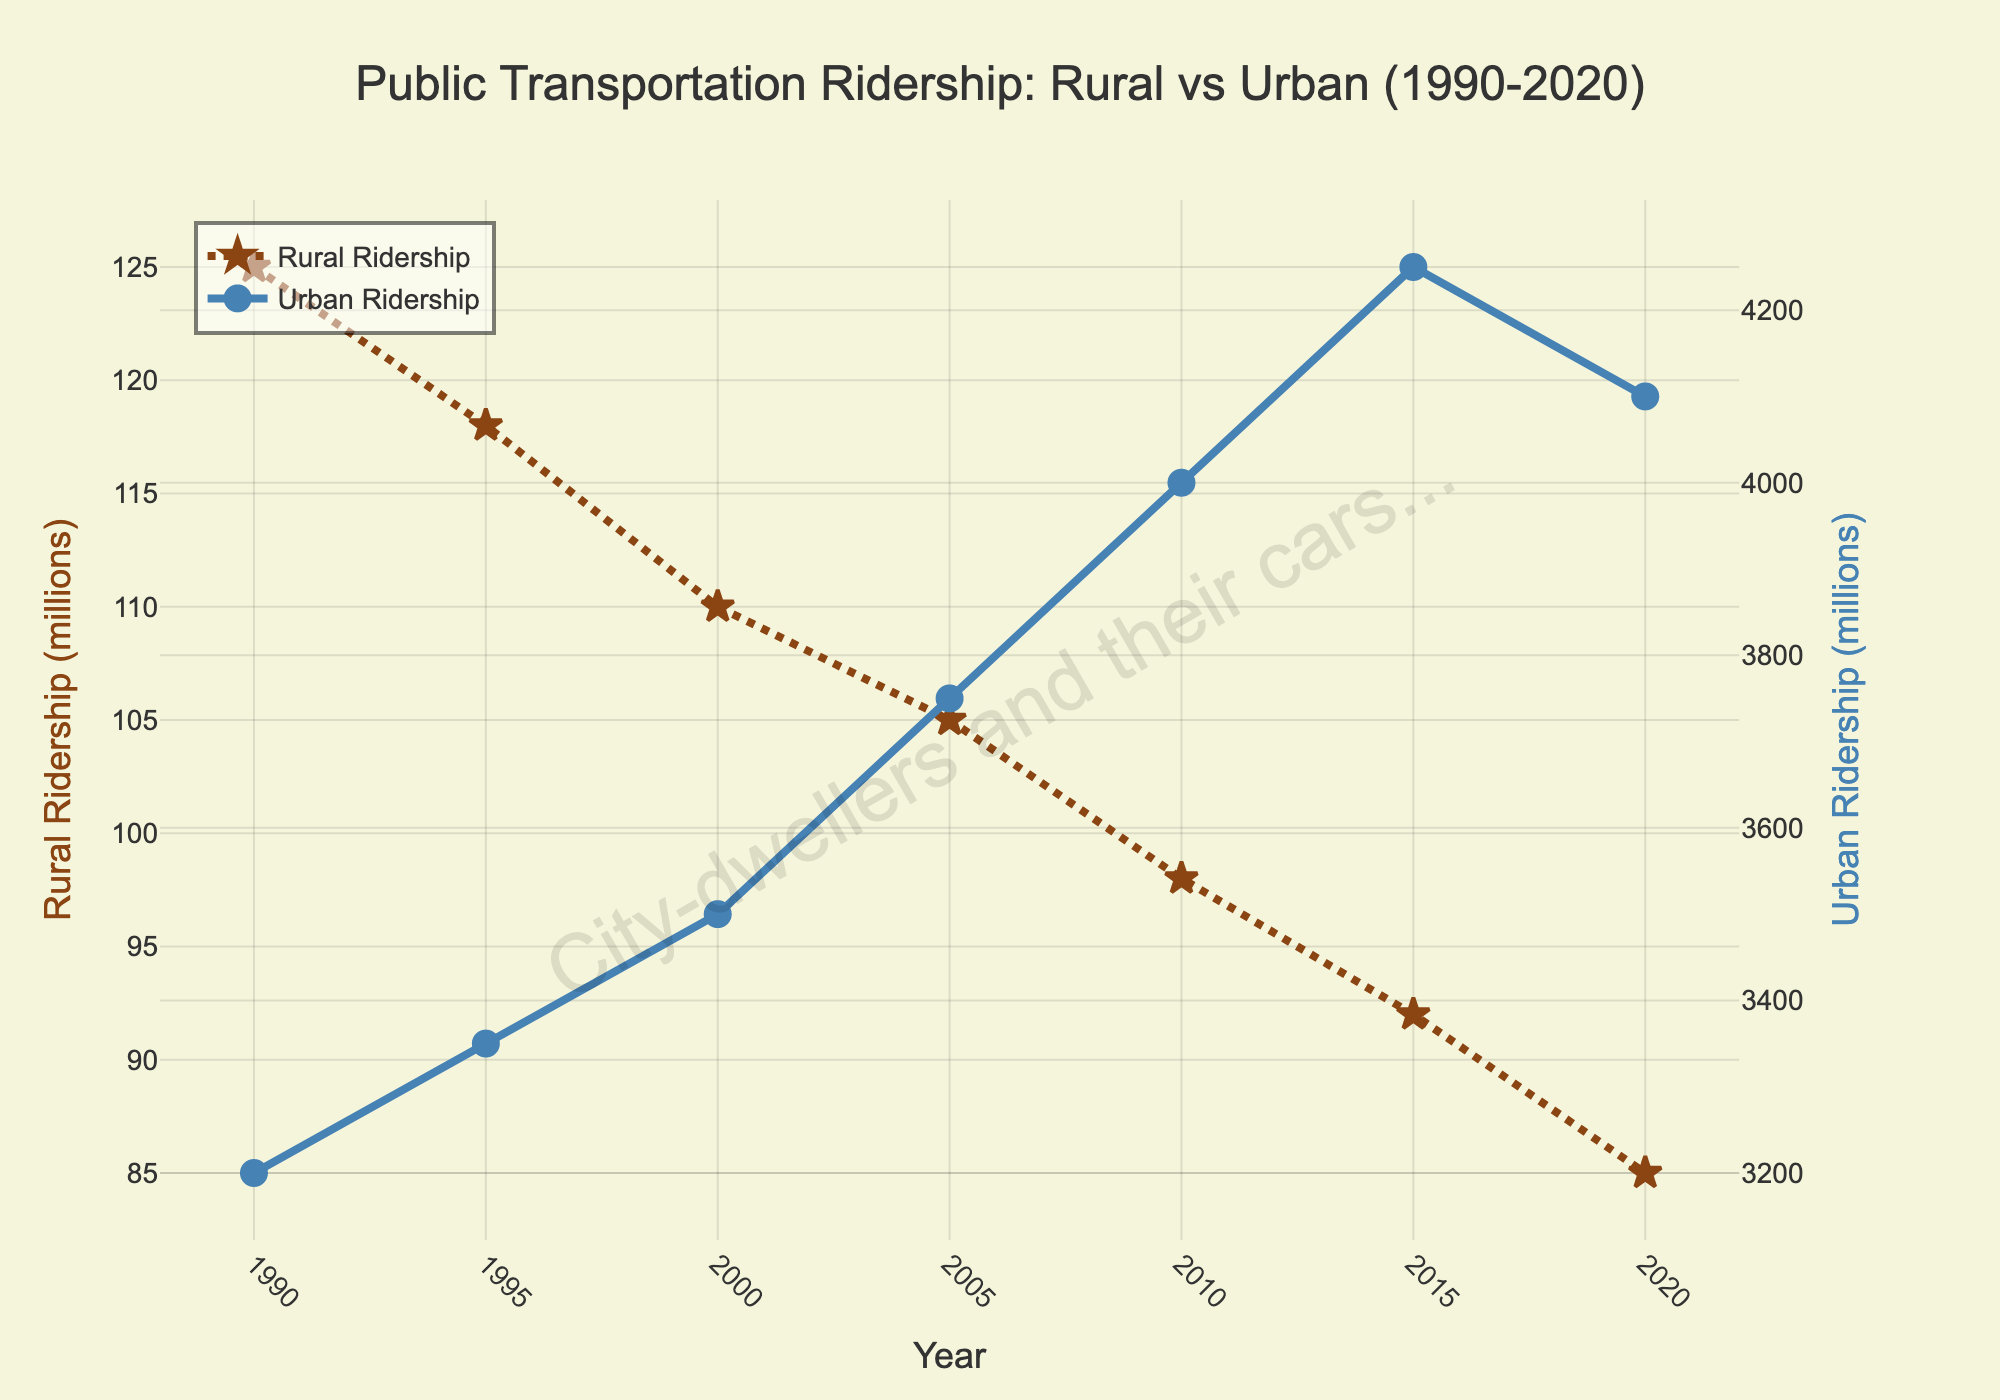What is the trend in rural ridership from 1990 to 2020? The rural ridership shows a continuous decline from 125 million in 1990 to 85 million in 2020. The trend is a steady decrease over the 30-year period.
Answer: Continuous decline How does urban ridership in 2020 compare to urban ridership in 1990? In 1990, urban ridership was 3200 million, and in 2020, it increased to 4100 million. The increase in urban ridership over this period is 4100 million - 3200 million = 900 million.
Answer: 900 million increase What is the difference between the highest urban ridership and the lowest rural ridership within the period? The highest urban ridership is 4250 million in 2015, and the lowest rural ridership is 85 million in 2020. The difference is 4250 million - 85 million = 4165 million.
Answer: 4165 million What is the average annual decline in rural ridership from 1990 to 2020? Calculate the total decline from 1990 to 2020, which is 125 million - 85 million = 40 million. Then divide by the number of years (30) to find the average annual decline, which is 40/30 ≈ 1.33 million per year.
Answer: Approximately 1.33 million per year What is the visual difference in markers between rural and urban ridership lines on the chart? The rural ridership line uses star-shaped markers, while the urban ridership line uses circle-shaped markers. The rural line has a dotted style, and the urban line is solid.
Answer: Star vs. Circle 